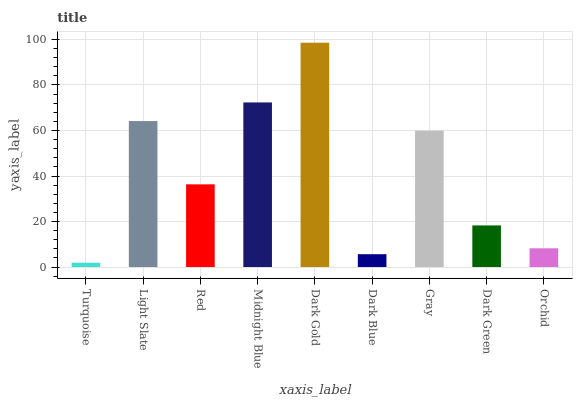Is Turquoise the minimum?
Answer yes or no. Yes. Is Dark Gold the maximum?
Answer yes or no. Yes. Is Light Slate the minimum?
Answer yes or no. No. Is Light Slate the maximum?
Answer yes or no. No. Is Light Slate greater than Turquoise?
Answer yes or no. Yes. Is Turquoise less than Light Slate?
Answer yes or no. Yes. Is Turquoise greater than Light Slate?
Answer yes or no. No. Is Light Slate less than Turquoise?
Answer yes or no. No. Is Red the high median?
Answer yes or no. Yes. Is Red the low median?
Answer yes or no. Yes. Is Midnight Blue the high median?
Answer yes or no. No. Is Dark Green the low median?
Answer yes or no. No. 